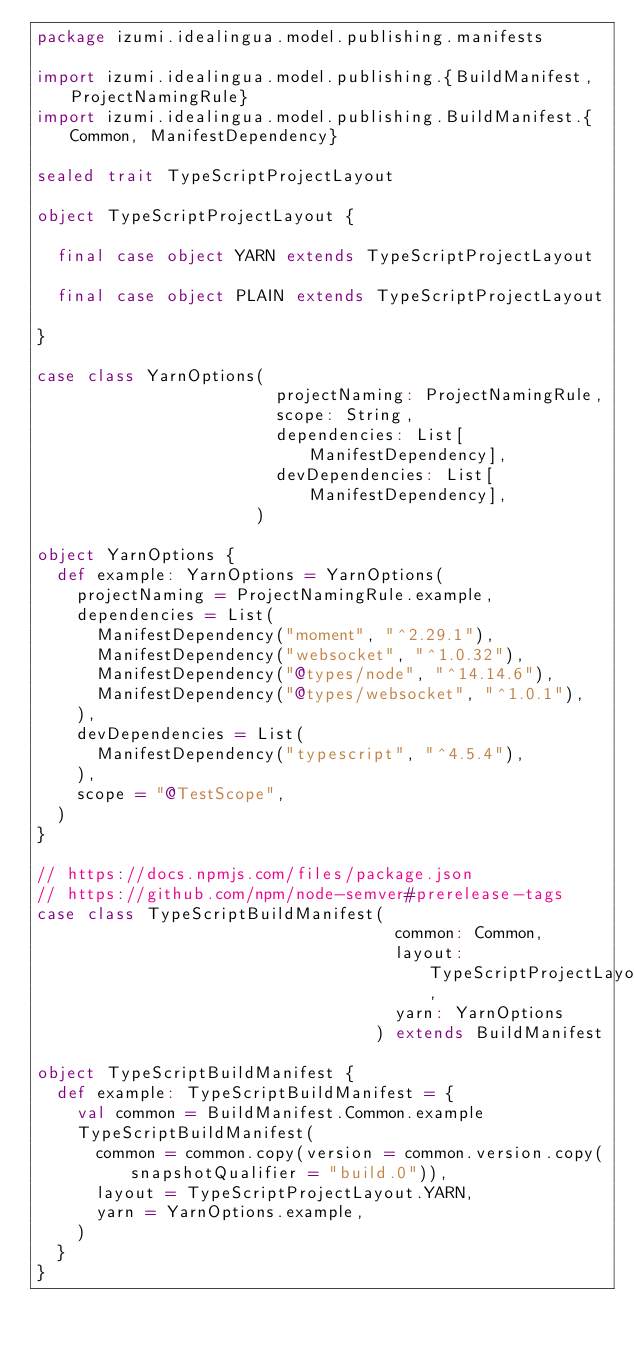<code> <loc_0><loc_0><loc_500><loc_500><_Scala_>package izumi.idealingua.model.publishing.manifests

import izumi.idealingua.model.publishing.{BuildManifest, ProjectNamingRule}
import izumi.idealingua.model.publishing.BuildManifest.{Common, ManifestDependency}

sealed trait TypeScriptProjectLayout

object TypeScriptProjectLayout {

  final case object YARN extends TypeScriptProjectLayout

  final case object PLAIN extends TypeScriptProjectLayout

}

case class YarnOptions(
                        projectNaming: ProjectNamingRule,
                        scope: String,
                        dependencies: List[ManifestDependency],
                        devDependencies: List[ManifestDependency],
                      )

object YarnOptions {
  def example: YarnOptions = YarnOptions(
    projectNaming = ProjectNamingRule.example,
    dependencies = List(
      ManifestDependency("moment", "^2.29.1"),
      ManifestDependency("websocket", "^1.0.32"),
      ManifestDependency("@types/node", "^14.14.6"),
      ManifestDependency("@types/websocket", "^1.0.1"),
    ),
    devDependencies = List(
      ManifestDependency("typescript", "^4.5.4"),
    ),
    scope = "@TestScope",
  )
}

// https://docs.npmjs.com/files/package.json
// https://github.com/npm/node-semver#prerelease-tags
case class TypeScriptBuildManifest(
                                    common: Common,
                                    layout: TypeScriptProjectLayout,
                                    yarn: YarnOptions
                                  ) extends BuildManifest

object TypeScriptBuildManifest {
  def example: TypeScriptBuildManifest = {
    val common = BuildManifest.Common.example
    TypeScriptBuildManifest(
      common = common.copy(version = common.version.copy(snapshotQualifier = "build.0")),
      layout = TypeScriptProjectLayout.YARN,
      yarn = YarnOptions.example,
    )
  }
}
</code> 